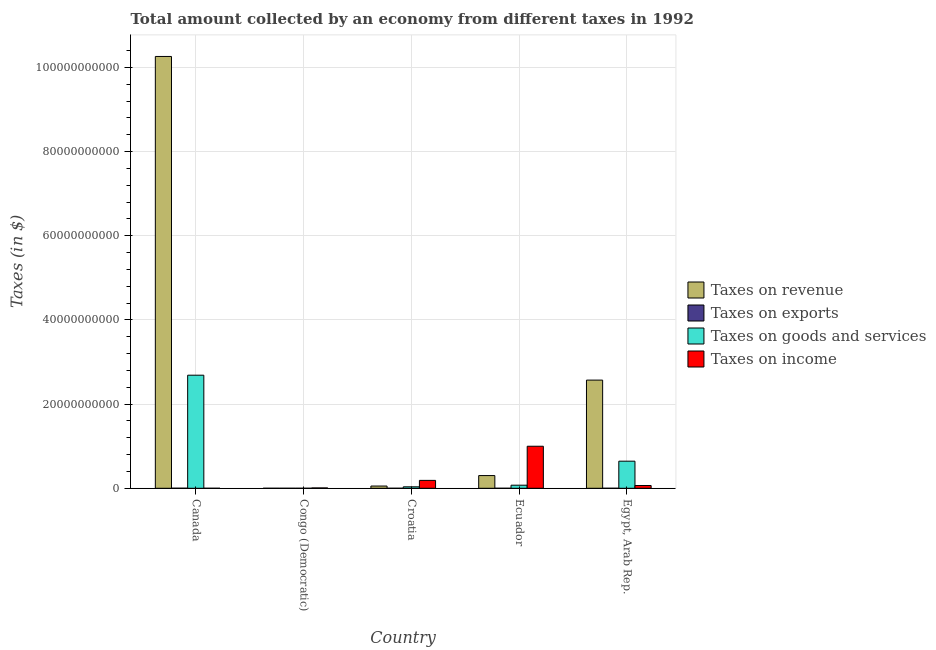How many different coloured bars are there?
Ensure brevity in your answer.  4. How many groups of bars are there?
Your response must be concise. 5. Are the number of bars per tick equal to the number of legend labels?
Make the answer very short. Yes. Are the number of bars on each tick of the X-axis equal?
Provide a short and direct response. Yes. How many bars are there on the 3rd tick from the right?
Offer a very short reply. 4. What is the label of the 5th group of bars from the left?
Offer a very short reply. Egypt, Arab Rep. In how many cases, is the number of bars for a given country not equal to the number of legend labels?
Offer a terse response. 0. What is the amount collected as tax on income in Croatia?
Make the answer very short. 1.88e+09. Across all countries, what is the maximum amount collected as tax on revenue?
Offer a terse response. 1.03e+11. What is the total amount collected as tax on exports in the graph?
Offer a very short reply. 1.54e+07. What is the difference between the amount collected as tax on exports in Canada and that in Ecuador?
Provide a succinct answer. 1.15e+07. What is the difference between the amount collected as tax on goods in Canada and the amount collected as tax on exports in Egypt, Arab Rep.?
Make the answer very short. 2.69e+1. What is the average amount collected as tax on income per country?
Give a very brief answer. 2.52e+09. What is the difference between the amount collected as tax on revenue and amount collected as tax on exports in Croatia?
Give a very brief answer. 5.32e+08. What is the ratio of the amount collected as tax on income in Croatia to that in Egypt, Arab Rep.?
Ensure brevity in your answer.  2.84. Is the amount collected as tax on exports in Canada less than that in Croatia?
Your response must be concise. No. Is the difference between the amount collected as tax on revenue in Congo (Democratic) and Egypt, Arab Rep. greater than the difference between the amount collected as tax on exports in Congo (Democratic) and Egypt, Arab Rep.?
Your response must be concise. No. What is the difference between the highest and the second highest amount collected as tax on income?
Provide a short and direct response. 8.11e+09. What is the difference between the highest and the lowest amount collected as tax on income?
Provide a short and direct response. 9.99e+09. Is it the case that in every country, the sum of the amount collected as tax on goods and amount collected as tax on revenue is greater than the sum of amount collected as tax on exports and amount collected as tax on income?
Keep it short and to the point. No. What does the 1st bar from the left in Canada represents?
Provide a short and direct response. Taxes on revenue. What does the 4th bar from the right in Canada represents?
Make the answer very short. Taxes on revenue. How many bars are there?
Offer a terse response. 20. Are all the bars in the graph horizontal?
Keep it short and to the point. No. How many countries are there in the graph?
Offer a terse response. 5. What is the difference between two consecutive major ticks on the Y-axis?
Give a very brief answer. 2.00e+1. Does the graph contain any zero values?
Keep it short and to the point. No. Does the graph contain grids?
Make the answer very short. Yes. Where does the legend appear in the graph?
Make the answer very short. Center right. What is the title of the graph?
Your answer should be very brief. Total amount collected by an economy from different taxes in 1992. Does "Rule based governance" appear as one of the legend labels in the graph?
Offer a very short reply. No. What is the label or title of the X-axis?
Keep it short and to the point. Country. What is the label or title of the Y-axis?
Your answer should be compact. Taxes (in $). What is the Taxes (in $) of Taxes on revenue in Canada?
Offer a very short reply. 1.03e+11. What is the Taxes (in $) of Taxes on exports in Canada?
Offer a terse response. 1.18e+07. What is the Taxes (in $) of Taxes on goods and services in Canada?
Provide a short and direct response. 2.69e+1. What is the Taxes (in $) of Taxes on income in Canada?
Provide a succinct answer. 104.33. What is the Taxes (in $) in Taxes on revenue in Congo (Democratic)?
Provide a short and direct response. 482.66. What is the Taxes (in $) of Taxes on exports in Congo (Democratic)?
Your response must be concise. 3.20e+05. What is the Taxes (in $) of Taxes on goods and services in Congo (Democratic)?
Your response must be concise. 188.26. What is the Taxes (in $) in Taxes on income in Congo (Democratic)?
Your answer should be compact. 8.40e+07. What is the Taxes (in $) in Taxes on revenue in Croatia?
Offer a terse response. 5.34e+08. What is the Taxes (in $) in Taxes on exports in Croatia?
Make the answer very short. 2.04e+06. What is the Taxes (in $) of Taxes on goods and services in Croatia?
Make the answer very short. 3.46e+08. What is the Taxes (in $) in Taxes on income in Croatia?
Make the answer very short. 1.88e+09. What is the Taxes (in $) of Taxes on revenue in Ecuador?
Your answer should be compact. 3.02e+09. What is the Taxes (in $) in Taxes on goods and services in Ecuador?
Provide a short and direct response. 7.34e+08. What is the Taxes (in $) in Taxes on income in Ecuador?
Provide a succinct answer. 9.99e+09. What is the Taxes (in $) in Taxes on revenue in Egypt, Arab Rep.?
Your response must be concise. 2.57e+1. What is the Taxes (in $) in Taxes on exports in Egypt, Arab Rep.?
Give a very brief answer. 8.80e+05. What is the Taxes (in $) of Taxes on goods and services in Egypt, Arab Rep.?
Your answer should be compact. 6.44e+09. What is the Taxes (in $) of Taxes on income in Egypt, Arab Rep.?
Keep it short and to the point. 6.60e+08. Across all countries, what is the maximum Taxes (in $) in Taxes on revenue?
Ensure brevity in your answer.  1.03e+11. Across all countries, what is the maximum Taxes (in $) of Taxes on exports?
Make the answer very short. 1.18e+07. Across all countries, what is the maximum Taxes (in $) in Taxes on goods and services?
Your answer should be compact. 2.69e+1. Across all countries, what is the maximum Taxes (in $) of Taxes on income?
Give a very brief answer. 9.99e+09. Across all countries, what is the minimum Taxes (in $) in Taxes on revenue?
Provide a short and direct response. 482.66. Across all countries, what is the minimum Taxes (in $) in Taxes on exports?
Offer a terse response. 3.10e+05. Across all countries, what is the minimum Taxes (in $) of Taxes on goods and services?
Give a very brief answer. 188.26. Across all countries, what is the minimum Taxes (in $) of Taxes on income?
Give a very brief answer. 104.33. What is the total Taxes (in $) of Taxes on revenue in the graph?
Give a very brief answer. 1.32e+11. What is the total Taxes (in $) in Taxes on exports in the graph?
Offer a terse response. 1.54e+07. What is the total Taxes (in $) in Taxes on goods and services in the graph?
Offer a terse response. 3.44e+1. What is the total Taxes (in $) in Taxes on income in the graph?
Provide a short and direct response. 1.26e+1. What is the difference between the Taxes (in $) in Taxes on revenue in Canada and that in Congo (Democratic)?
Offer a terse response. 1.03e+11. What is the difference between the Taxes (in $) of Taxes on exports in Canada and that in Congo (Democratic)?
Make the answer very short. 1.15e+07. What is the difference between the Taxes (in $) of Taxes on goods and services in Canada and that in Congo (Democratic)?
Provide a succinct answer. 2.69e+1. What is the difference between the Taxes (in $) of Taxes on income in Canada and that in Congo (Democratic)?
Your answer should be compact. -8.40e+07. What is the difference between the Taxes (in $) in Taxes on revenue in Canada and that in Croatia?
Ensure brevity in your answer.  1.02e+11. What is the difference between the Taxes (in $) in Taxes on exports in Canada and that in Croatia?
Provide a succinct answer. 9.79e+06. What is the difference between the Taxes (in $) in Taxes on goods and services in Canada and that in Croatia?
Your answer should be very brief. 2.65e+1. What is the difference between the Taxes (in $) in Taxes on income in Canada and that in Croatia?
Make the answer very short. -1.88e+09. What is the difference between the Taxes (in $) in Taxes on revenue in Canada and that in Ecuador?
Provide a short and direct response. 9.96e+1. What is the difference between the Taxes (in $) of Taxes on exports in Canada and that in Ecuador?
Provide a succinct answer. 1.15e+07. What is the difference between the Taxes (in $) in Taxes on goods and services in Canada and that in Ecuador?
Make the answer very short. 2.61e+1. What is the difference between the Taxes (in $) of Taxes on income in Canada and that in Ecuador?
Provide a succinct answer. -9.99e+09. What is the difference between the Taxes (in $) of Taxes on revenue in Canada and that in Egypt, Arab Rep.?
Your answer should be very brief. 7.69e+1. What is the difference between the Taxes (in $) of Taxes on exports in Canada and that in Egypt, Arab Rep.?
Provide a succinct answer. 1.10e+07. What is the difference between the Taxes (in $) in Taxes on goods and services in Canada and that in Egypt, Arab Rep.?
Your response must be concise. 2.04e+1. What is the difference between the Taxes (in $) in Taxes on income in Canada and that in Egypt, Arab Rep.?
Make the answer very short. -6.60e+08. What is the difference between the Taxes (in $) of Taxes on revenue in Congo (Democratic) and that in Croatia?
Offer a terse response. -5.34e+08. What is the difference between the Taxes (in $) of Taxes on exports in Congo (Democratic) and that in Croatia?
Make the answer very short. -1.72e+06. What is the difference between the Taxes (in $) of Taxes on goods and services in Congo (Democratic) and that in Croatia?
Your answer should be very brief. -3.46e+08. What is the difference between the Taxes (in $) in Taxes on income in Congo (Democratic) and that in Croatia?
Your response must be concise. -1.79e+09. What is the difference between the Taxes (in $) in Taxes on revenue in Congo (Democratic) and that in Ecuador?
Your response must be concise. -3.02e+09. What is the difference between the Taxes (in $) in Taxes on goods and services in Congo (Democratic) and that in Ecuador?
Your answer should be compact. -7.34e+08. What is the difference between the Taxes (in $) of Taxes on income in Congo (Democratic) and that in Ecuador?
Your response must be concise. -9.90e+09. What is the difference between the Taxes (in $) in Taxes on revenue in Congo (Democratic) and that in Egypt, Arab Rep.?
Give a very brief answer. -2.57e+1. What is the difference between the Taxes (in $) in Taxes on exports in Congo (Democratic) and that in Egypt, Arab Rep.?
Make the answer very short. -5.60e+05. What is the difference between the Taxes (in $) of Taxes on goods and services in Congo (Democratic) and that in Egypt, Arab Rep.?
Give a very brief answer. -6.44e+09. What is the difference between the Taxes (in $) in Taxes on income in Congo (Democratic) and that in Egypt, Arab Rep.?
Offer a terse response. -5.76e+08. What is the difference between the Taxes (in $) of Taxes on revenue in Croatia and that in Ecuador?
Offer a very short reply. -2.49e+09. What is the difference between the Taxes (in $) in Taxes on exports in Croatia and that in Ecuador?
Keep it short and to the point. 1.73e+06. What is the difference between the Taxes (in $) in Taxes on goods and services in Croatia and that in Ecuador?
Ensure brevity in your answer.  -3.88e+08. What is the difference between the Taxes (in $) in Taxes on income in Croatia and that in Ecuador?
Provide a succinct answer. -8.11e+09. What is the difference between the Taxes (in $) in Taxes on revenue in Croatia and that in Egypt, Arab Rep.?
Provide a short and direct response. -2.52e+1. What is the difference between the Taxes (in $) of Taxes on exports in Croatia and that in Egypt, Arab Rep.?
Your answer should be very brief. 1.16e+06. What is the difference between the Taxes (in $) in Taxes on goods and services in Croatia and that in Egypt, Arab Rep.?
Your answer should be very brief. -6.09e+09. What is the difference between the Taxes (in $) in Taxes on income in Croatia and that in Egypt, Arab Rep.?
Your answer should be compact. 1.22e+09. What is the difference between the Taxes (in $) of Taxes on revenue in Ecuador and that in Egypt, Arab Rep.?
Your answer should be very brief. -2.27e+1. What is the difference between the Taxes (in $) in Taxes on exports in Ecuador and that in Egypt, Arab Rep.?
Keep it short and to the point. -5.70e+05. What is the difference between the Taxes (in $) of Taxes on goods and services in Ecuador and that in Egypt, Arab Rep.?
Keep it short and to the point. -5.70e+09. What is the difference between the Taxes (in $) in Taxes on income in Ecuador and that in Egypt, Arab Rep.?
Offer a very short reply. 9.33e+09. What is the difference between the Taxes (in $) of Taxes on revenue in Canada and the Taxes (in $) of Taxes on exports in Congo (Democratic)?
Your answer should be compact. 1.03e+11. What is the difference between the Taxes (in $) in Taxes on revenue in Canada and the Taxes (in $) in Taxes on goods and services in Congo (Democratic)?
Your answer should be very brief. 1.03e+11. What is the difference between the Taxes (in $) of Taxes on revenue in Canada and the Taxes (in $) of Taxes on income in Congo (Democratic)?
Provide a succinct answer. 1.03e+11. What is the difference between the Taxes (in $) of Taxes on exports in Canada and the Taxes (in $) of Taxes on goods and services in Congo (Democratic)?
Your answer should be compact. 1.18e+07. What is the difference between the Taxes (in $) of Taxes on exports in Canada and the Taxes (in $) of Taxes on income in Congo (Democratic)?
Keep it short and to the point. -7.22e+07. What is the difference between the Taxes (in $) in Taxes on goods and services in Canada and the Taxes (in $) in Taxes on income in Congo (Democratic)?
Your answer should be compact. 2.68e+1. What is the difference between the Taxes (in $) in Taxes on revenue in Canada and the Taxes (in $) in Taxes on exports in Croatia?
Give a very brief answer. 1.03e+11. What is the difference between the Taxes (in $) of Taxes on revenue in Canada and the Taxes (in $) of Taxes on goods and services in Croatia?
Your response must be concise. 1.02e+11. What is the difference between the Taxes (in $) in Taxes on revenue in Canada and the Taxes (in $) in Taxes on income in Croatia?
Offer a very short reply. 1.01e+11. What is the difference between the Taxes (in $) in Taxes on exports in Canada and the Taxes (in $) in Taxes on goods and services in Croatia?
Offer a terse response. -3.34e+08. What is the difference between the Taxes (in $) in Taxes on exports in Canada and the Taxes (in $) in Taxes on income in Croatia?
Ensure brevity in your answer.  -1.86e+09. What is the difference between the Taxes (in $) in Taxes on goods and services in Canada and the Taxes (in $) in Taxes on income in Croatia?
Provide a short and direct response. 2.50e+1. What is the difference between the Taxes (in $) in Taxes on revenue in Canada and the Taxes (in $) in Taxes on exports in Ecuador?
Give a very brief answer. 1.03e+11. What is the difference between the Taxes (in $) of Taxes on revenue in Canada and the Taxes (in $) of Taxes on goods and services in Ecuador?
Provide a succinct answer. 1.02e+11. What is the difference between the Taxes (in $) of Taxes on revenue in Canada and the Taxes (in $) of Taxes on income in Ecuador?
Your answer should be very brief. 9.26e+1. What is the difference between the Taxes (in $) of Taxes on exports in Canada and the Taxes (in $) of Taxes on goods and services in Ecuador?
Keep it short and to the point. -7.22e+08. What is the difference between the Taxes (in $) in Taxes on exports in Canada and the Taxes (in $) in Taxes on income in Ecuador?
Keep it short and to the point. -9.98e+09. What is the difference between the Taxes (in $) of Taxes on goods and services in Canada and the Taxes (in $) of Taxes on income in Ecuador?
Your response must be concise. 1.69e+1. What is the difference between the Taxes (in $) of Taxes on revenue in Canada and the Taxes (in $) of Taxes on exports in Egypt, Arab Rep.?
Give a very brief answer. 1.03e+11. What is the difference between the Taxes (in $) of Taxes on revenue in Canada and the Taxes (in $) of Taxes on goods and services in Egypt, Arab Rep.?
Provide a short and direct response. 9.62e+1. What is the difference between the Taxes (in $) in Taxes on revenue in Canada and the Taxes (in $) in Taxes on income in Egypt, Arab Rep.?
Keep it short and to the point. 1.02e+11. What is the difference between the Taxes (in $) of Taxes on exports in Canada and the Taxes (in $) of Taxes on goods and services in Egypt, Arab Rep.?
Your response must be concise. -6.43e+09. What is the difference between the Taxes (in $) of Taxes on exports in Canada and the Taxes (in $) of Taxes on income in Egypt, Arab Rep.?
Your response must be concise. -6.48e+08. What is the difference between the Taxes (in $) of Taxes on goods and services in Canada and the Taxes (in $) of Taxes on income in Egypt, Arab Rep.?
Give a very brief answer. 2.62e+1. What is the difference between the Taxes (in $) in Taxes on revenue in Congo (Democratic) and the Taxes (in $) in Taxes on exports in Croatia?
Provide a succinct answer. -2.04e+06. What is the difference between the Taxes (in $) in Taxes on revenue in Congo (Democratic) and the Taxes (in $) in Taxes on goods and services in Croatia?
Offer a terse response. -3.46e+08. What is the difference between the Taxes (in $) in Taxes on revenue in Congo (Democratic) and the Taxes (in $) in Taxes on income in Croatia?
Your answer should be compact. -1.88e+09. What is the difference between the Taxes (in $) in Taxes on exports in Congo (Democratic) and the Taxes (in $) in Taxes on goods and services in Croatia?
Offer a terse response. -3.46e+08. What is the difference between the Taxes (in $) of Taxes on exports in Congo (Democratic) and the Taxes (in $) of Taxes on income in Croatia?
Your answer should be very brief. -1.88e+09. What is the difference between the Taxes (in $) in Taxes on goods and services in Congo (Democratic) and the Taxes (in $) in Taxes on income in Croatia?
Provide a short and direct response. -1.88e+09. What is the difference between the Taxes (in $) in Taxes on revenue in Congo (Democratic) and the Taxes (in $) in Taxes on exports in Ecuador?
Offer a very short reply. -3.10e+05. What is the difference between the Taxes (in $) of Taxes on revenue in Congo (Democratic) and the Taxes (in $) of Taxes on goods and services in Ecuador?
Offer a terse response. -7.34e+08. What is the difference between the Taxes (in $) of Taxes on revenue in Congo (Democratic) and the Taxes (in $) of Taxes on income in Ecuador?
Offer a very short reply. -9.99e+09. What is the difference between the Taxes (in $) in Taxes on exports in Congo (Democratic) and the Taxes (in $) in Taxes on goods and services in Ecuador?
Offer a very short reply. -7.34e+08. What is the difference between the Taxes (in $) of Taxes on exports in Congo (Democratic) and the Taxes (in $) of Taxes on income in Ecuador?
Make the answer very short. -9.99e+09. What is the difference between the Taxes (in $) of Taxes on goods and services in Congo (Democratic) and the Taxes (in $) of Taxes on income in Ecuador?
Offer a very short reply. -9.99e+09. What is the difference between the Taxes (in $) in Taxes on revenue in Congo (Democratic) and the Taxes (in $) in Taxes on exports in Egypt, Arab Rep.?
Provide a succinct answer. -8.80e+05. What is the difference between the Taxes (in $) of Taxes on revenue in Congo (Democratic) and the Taxes (in $) of Taxes on goods and services in Egypt, Arab Rep.?
Make the answer very short. -6.44e+09. What is the difference between the Taxes (in $) of Taxes on revenue in Congo (Democratic) and the Taxes (in $) of Taxes on income in Egypt, Arab Rep.?
Provide a succinct answer. -6.60e+08. What is the difference between the Taxes (in $) in Taxes on exports in Congo (Democratic) and the Taxes (in $) in Taxes on goods and services in Egypt, Arab Rep.?
Keep it short and to the point. -6.44e+09. What is the difference between the Taxes (in $) in Taxes on exports in Congo (Democratic) and the Taxes (in $) in Taxes on income in Egypt, Arab Rep.?
Ensure brevity in your answer.  -6.60e+08. What is the difference between the Taxes (in $) in Taxes on goods and services in Congo (Democratic) and the Taxes (in $) in Taxes on income in Egypt, Arab Rep.?
Your answer should be compact. -6.60e+08. What is the difference between the Taxes (in $) in Taxes on revenue in Croatia and the Taxes (in $) in Taxes on exports in Ecuador?
Offer a terse response. 5.34e+08. What is the difference between the Taxes (in $) of Taxes on revenue in Croatia and the Taxes (in $) of Taxes on goods and services in Ecuador?
Offer a terse response. -2.00e+08. What is the difference between the Taxes (in $) of Taxes on revenue in Croatia and the Taxes (in $) of Taxes on income in Ecuador?
Keep it short and to the point. -9.45e+09. What is the difference between the Taxes (in $) of Taxes on exports in Croatia and the Taxes (in $) of Taxes on goods and services in Ecuador?
Your answer should be compact. -7.32e+08. What is the difference between the Taxes (in $) in Taxes on exports in Croatia and the Taxes (in $) in Taxes on income in Ecuador?
Make the answer very short. -9.99e+09. What is the difference between the Taxes (in $) in Taxes on goods and services in Croatia and the Taxes (in $) in Taxes on income in Ecuador?
Give a very brief answer. -9.64e+09. What is the difference between the Taxes (in $) of Taxes on revenue in Croatia and the Taxes (in $) of Taxes on exports in Egypt, Arab Rep.?
Provide a succinct answer. 5.33e+08. What is the difference between the Taxes (in $) in Taxes on revenue in Croatia and the Taxes (in $) in Taxes on goods and services in Egypt, Arab Rep.?
Offer a terse response. -5.90e+09. What is the difference between the Taxes (in $) of Taxes on revenue in Croatia and the Taxes (in $) of Taxes on income in Egypt, Arab Rep.?
Offer a terse response. -1.26e+08. What is the difference between the Taxes (in $) in Taxes on exports in Croatia and the Taxes (in $) in Taxes on goods and services in Egypt, Arab Rep.?
Your response must be concise. -6.44e+09. What is the difference between the Taxes (in $) of Taxes on exports in Croatia and the Taxes (in $) of Taxes on income in Egypt, Arab Rep.?
Your answer should be very brief. -6.58e+08. What is the difference between the Taxes (in $) in Taxes on goods and services in Croatia and the Taxes (in $) in Taxes on income in Egypt, Arab Rep.?
Your response must be concise. -3.14e+08. What is the difference between the Taxes (in $) in Taxes on revenue in Ecuador and the Taxes (in $) in Taxes on exports in Egypt, Arab Rep.?
Keep it short and to the point. 3.02e+09. What is the difference between the Taxes (in $) of Taxes on revenue in Ecuador and the Taxes (in $) of Taxes on goods and services in Egypt, Arab Rep.?
Your response must be concise. -3.42e+09. What is the difference between the Taxes (in $) of Taxes on revenue in Ecuador and the Taxes (in $) of Taxes on income in Egypt, Arab Rep.?
Give a very brief answer. 2.36e+09. What is the difference between the Taxes (in $) in Taxes on exports in Ecuador and the Taxes (in $) in Taxes on goods and services in Egypt, Arab Rep.?
Keep it short and to the point. -6.44e+09. What is the difference between the Taxes (in $) of Taxes on exports in Ecuador and the Taxes (in $) of Taxes on income in Egypt, Arab Rep.?
Your answer should be very brief. -6.60e+08. What is the difference between the Taxes (in $) in Taxes on goods and services in Ecuador and the Taxes (in $) in Taxes on income in Egypt, Arab Rep.?
Ensure brevity in your answer.  7.40e+07. What is the average Taxes (in $) in Taxes on revenue per country?
Make the answer very short. 2.64e+1. What is the average Taxes (in $) of Taxes on exports per country?
Offer a very short reply. 3.08e+06. What is the average Taxes (in $) of Taxes on goods and services per country?
Provide a succinct answer. 6.88e+09. What is the average Taxes (in $) in Taxes on income per country?
Provide a succinct answer. 2.52e+09. What is the difference between the Taxes (in $) of Taxes on revenue and Taxes (in $) of Taxes on exports in Canada?
Ensure brevity in your answer.  1.03e+11. What is the difference between the Taxes (in $) in Taxes on revenue and Taxes (in $) in Taxes on goods and services in Canada?
Offer a very short reply. 7.57e+1. What is the difference between the Taxes (in $) of Taxes on revenue and Taxes (in $) of Taxes on income in Canada?
Your answer should be very brief. 1.03e+11. What is the difference between the Taxes (in $) of Taxes on exports and Taxes (in $) of Taxes on goods and services in Canada?
Give a very brief answer. -2.69e+1. What is the difference between the Taxes (in $) in Taxes on exports and Taxes (in $) in Taxes on income in Canada?
Offer a terse response. 1.18e+07. What is the difference between the Taxes (in $) of Taxes on goods and services and Taxes (in $) of Taxes on income in Canada?
Your answer should be very brief. 2.69e+1. What is the difference between the Taxes (in $) of Taxes on revenue and Taxes (in $) of Taxes on exports in Congo (Democratic)?
Offer a very short reply. -3.20e+05. What is the difference between the Taxes (in $) of Taxes on revenue and Taxes (in $) of Taxes on goods and services in Congo (Democratic)?
Provide a succinct answer. 294.4. What is the difference between the Taxes (in $) of Taxes on revenue and Taxes (in $) of Taxes on income in Congo (Democratic)?
Your response must be concise. -8.40e+07. What is the difference between the Taxes (in $) of Taxes on exports and Taxes (in $) of Taxes on goods and services in Congo (Democratic)?
Offer a very short reply. 3.20e+05. What is the difference between the Taxes (in $) of Taxes on exports and Taxes (in $) of Taxes on income in Congo (Democratic)?
Your answer should be compact. -8.37e+07. What is the difference between the Taxes (in $) of Taxes on goods and services and Taxes (in $) of Taxes on income in Congo (Democratic)?
Ensure brevity in your answer.  -8.40e+07. What is the difference between the Taxes (in $) of Taxes on revenue and Taxes (in $) of Taxes on exports in Croatia?
Your response must be concise. 5.32e+08. What is the difference between the Taxes (in $) of Taxes on revenue and Taxes (in $) of Taxes on goods and services in Croatia?
Offer a terse response. 1.88e+08. What is the difference between the Taxes (in $) in Taxes on revenue and Taxes (in $) in Taxes on income in Croatia?
Provide a short and direct response. -1.34e+09. What is the difference between the Taxes (in $) in Taxes on exports and Taxes (in $) in Taxes on goods and services in Croatia?
Make the answer very short. -3.44e+08. What is the difference between the Taxes (in $) of Taxes on exports and Taxes (in $) of Taxes on income in Croatia?
Offer a very short reply. -1.87e+09. What is the difference between the Taxes (in $) of Taxes on goods and services and Taxes (in $) of Taxes on income in Croatia?
Your answer should be very brief. -1.53e+09. What is the difference between the Taxes (in $) of Taxes on revenue and Taxes (in $) of Taxes on exports in Ecuador?
Make the answer very short. 3.02e+09. What is the difference between the Taxes (in $) of Taxes on revenue and Taxes (in $) of Taxes on goods and services in Ecuador?
Offer a terse response. 2.29e+09. What is the difference between the Taxes (in $) in Taxes on revenue and Taxes (in $) in Taxes on income in Ecuador?
Give a very brief answer. -6.97e+09. What is the difference between the Taxes (in $) in Taxes on exports and Taxes (in $) in Taxes on goods and services in Ecuador?
Your answer should be compact. -7.34e+08. What is the difference between the Taxes (in $) of Taxes on exports and Taxes (in $) of Taxes on income in Ecuador?
Make the answer very short. -9.99e+09. What is the difference between the Taxes (in $) in Taxes on goods and services and Taxes (in $) in Taxes on income in Ecuador?
Keep it short and to the point. -9.26e+09. What is the difference between the Taxes (in $) of Taxes on revenue and Taxes (in $) of Taxes on exports in Egypt, Arab Rep.?
Keep it short and to the point. 2.57e+1. What is the difference between the Taxes (in $) of Taxes on revenue and Taxes (in $) of Taxes on goods and services in Egypt, Arab Rep.?
Provide a short and direct response. 1.93e+1. What is the difference between the Taxes (in $) in Taxes on revenue and Taxes (in $) in Taxes on income in Egypt, Arab Rep.?
Provide a short and direct response. 2.50e+1. What is the difference between the Taxes (in $) in Taxes on exports and Taxes (in $) in Taxes on goods and services in Egypt, Arab Rep.?
Offer a terse response. -6.44e+09. What is the difference between the Taxes (in $) of Taxes on exports and Taxes (in $) of Taxes on income in Egypt, Arab Rep.?
Offer a terse response. -6.59e+08. What is the difference between the Taxes (in $) of Taxes on goods and services and Taxes (in $) of Taxes on income in Egypt, Arab Rep.?
Make the answer very short. 5.78e+09. What is the ratio of the Taxes (in $) in Taxes on revenue in Canada to that in Congo (Democratic)?
Offer a terse response. 2.13e+08. What is the ratio of the Taxes (in $) in Taxes on exports in Canada to that in Congo (Democratic)?
Give a very brief answer. 36.97. What is the ratio of the Taxes (in $) in Taxes on goods and services in Canada to that in Congo (Democratic)?
Offer a terse response. 1.43e+08. What is the ratio of the Taxes (in $) in Taxes on income in Canada to that in Congo (Democratic)?
Provide a short and direct response. 0. What is the ratio of the Taxes (in $) in Taxes on revenue in Canada to that in Croatia?
Make the answer very short. 192.11. What is the ratio of the Taxes (in $) in Taxes on exports in Canada to that in Croatia?
Make the answer very short. 5.81. What is the ratio of the Taxes (in $) in Taxes on goods and services in Canada to that in Croatia?
Your answer should be compact. 77.62. What is the ratio of the Taxes (in $) in Taxes on revenue in Canada to that in Ecuador?
Provide a short and direct response. 33.96. What is the ratio of the Taxes (in $) in Taxes on exports in Canada to that in Ecuador?
Give a very brief answer. 38.16. What is the ratio of the Taxes (in $) of Taxes on goods and services in Canada to that in Ecuador?
Offer a very short reply. 36.61. What is the ratio of the Taxes (in $) of Taxes on revenue in Canada to that in Egypt, Arab Rep.?
Give a very brief answer. 3.99. What is the ratio of the Taxes (in $) in Taxes on exports in Canada to that in Egypt, Arab Rep.?
Make the answer very short. 13.44. What is the ratio of the Taxes (in $) of Taxes on goods and services in Canada to that in Egypt, Arab Rep.?
Offer a very short reply. 4.17. What is the ratio of the Taxes (in $) of Taxes on income in Canada to that in Egypt, Arab Rep.?
Provide a succinct answer. 0. What is the ratio of the Taxes (in $) in Taxes on exports in Congo (Democratic) to that in Croatia?
Offer a terse response. 0.16. What is the ratio of the Taxes (in $) in Taxes on goods and services in Congo (Democratic) to that in Croatia?
Give a very brief answer. 0. What is the ratio of the Taxes (in $) of Taxes on income in Congo (Democratic) to that in Croatia?
Your answer should be compact. 0.04. What is the ratio of the Taxes (in $) in Taxes on revenue in Congo (Democratic) to that in Ecuador?
Provide a short and direct response. 0. What is the ratio of the Taxes (in $) of Taxes on exports in Congo (Democratic) to that in Ecuador?
Offer a very short reply. 1.03. What is the ratio of the Taxes (in $) in Taxes on goods and services in Congo (Democratic) to that in Ecuador?
Ensure brevity in your answer.  0. What is the ratio of the Taxes (in $) in Taxes on income in Congo (Democratic) to that in Ecuador?
Offer a very short reply. 0.01. What is the ratio of the Taxes (in $) of Taxes on exports in Congo (Democratic) to that in Egypt, Arab Rep.?
Provide a succinct answer. 0.36. What is the ratio of the Taxes (in $) of Taxes on goods and services in Congo (Democratic) to that in Egypt, Arab Rep.?
Offer a terse response. 0. What is the ratio of the Taxes (in $) of Taxes on income in Congo (Democratic) to that in Egypt, Arab Rep.?
Your answer should be compact. 0.13. What is the ratio of the Taxes (in $) of Taxes on revenue in Croatia to that in Ecuador?
Offer a very short reply. 0.18. What is the ratio of the Taxes (in $) in Taxes on exports in Croatia to that in Ecuador?
Make the answer very short. 6.57. What is the ratio of the Taxes (in $) of Taxes on goods and services in Croatia to that in Ecuador?
Ensure brevity in your answer.  0.47. What is the ratio of the Taxes (in $) of Taxes on income in Croatia to that in Ecuador?
Your answer should be very brief. 0.19. What is the ratio of the Taxes (in $) of Taxes on revenue in Croatia to that in Egypt, Arab Rep.?
Provide a succinct answer. 0.02. What is the ratio of the Taxes (in $) in Taxes on exports in Croatia to that in Egypt, Arab Rep.?
Provide a succinct answer. 2.31. What is the ratio of the Taxes (in $) of Taxes on goods and services in Croatia to that in Egypt, Arab Rep.?
Offer a terse response. 0.05. What is the ratio of the Taxes (in $) in Taxes on income in Croatia to that in Egypt, Arab Rep.?
Give a very brief answer. 2.84. What is the ratio of the Taxes (in $) of Taxes on revenue in Ecuador to that in Egypt, Arab Rep.?
Keep it short and to the point. 0.12. What is the ratio of the Taxes (in $) in Taxes on exports in Ecuador to that in Egypt, Arab Rep.?
Provide a short and direct response. 0.35. What is the ratio of the Taxes (in $) of Taxes on goods and services in Ecuador to that in Egypt, Arab Rep.?
Make the answer very short. 0.11. What is the ratio of the Taxes (in $) of Taxes on income in Ecuador to that in Egypt, Arab Rep.?
Ensure brevity in your answer.  15.13. What is the difference between the highest and the second highest Taxes (in $) in Taxes on revenue?
Provide a short and direct response. 7.69e+1. What is the difference between the highest and the second highest Taxes (in $) of Taxes on exports?
Your answer should be compact. 9.79e+06. What is the difference between the highest and the second highest Taxes (in $) in Taxes on goods and services?
Keep it short and to the point. 2.04e+1. What is the difference between the highest and the second highest Taxes (in $) in Taxes on income?
Your answer should be compact. 8.11e+09. What is the difference between the highest and the lowest Taxes (in $) of Taxes on revenue?
Offer a very short reply. 1.03e+11. What is the difference between the highest and the lowest Taxes (in $) of Taxes on exports?
Your response must be concise. 1.15e+07. What is the difference between the highest and the lowest Taxes (in $) of Taxes on goods and services?
Your answer should be compact. 2.69e+1. What is the difference between the highest and the lowest Taxes (in $) of Taxes on income?
Provide a succinct answer. 9.99e+09. 